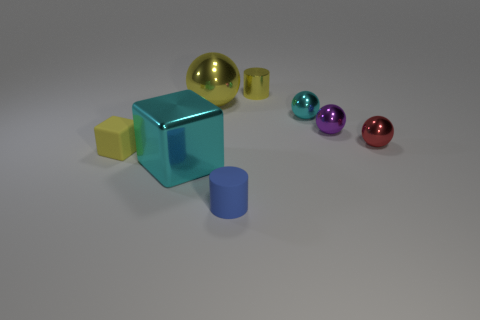Is there anything else that has the same size as the blue cylinder?
Give a very brief answer. Yes. What size is the shiny object behind the ball that is on the left side of the yellow shiny cylinder?
Make the answer very short. Small. What is the material of the thing that is the same size as the metal cube?
Offer a very short reply. Metal. Is there a large cube that has the same material as the large sphere?
Keep it short and to the point. Yes. There is a cylinder that is in front of the small cylinder that is behind the metal ball that is left of the tiny cyan shiny object; what is its color?
Give a very brief answer. Blue. Do the small matte object that is behind the blue thing and the metallic thing in front of the tiny yellow rubber cube have the same color?
Ensure brevity in your answer.  No. Is there anything else that is the same color as the big block?
Make the answer very short. Yes. Are there fewer blue things in front of the tiny blue matte cylinder than large cyan metallic objects?
Keep it short and to the point. Yes. How many big yellow shiny spheres are there?
Ensure brevity in your answer.  1. There is a big cyan object; is its shape the same as the small rubber thing that is behind the small matte cylinder?
Keep it short and to the point. Yes. 